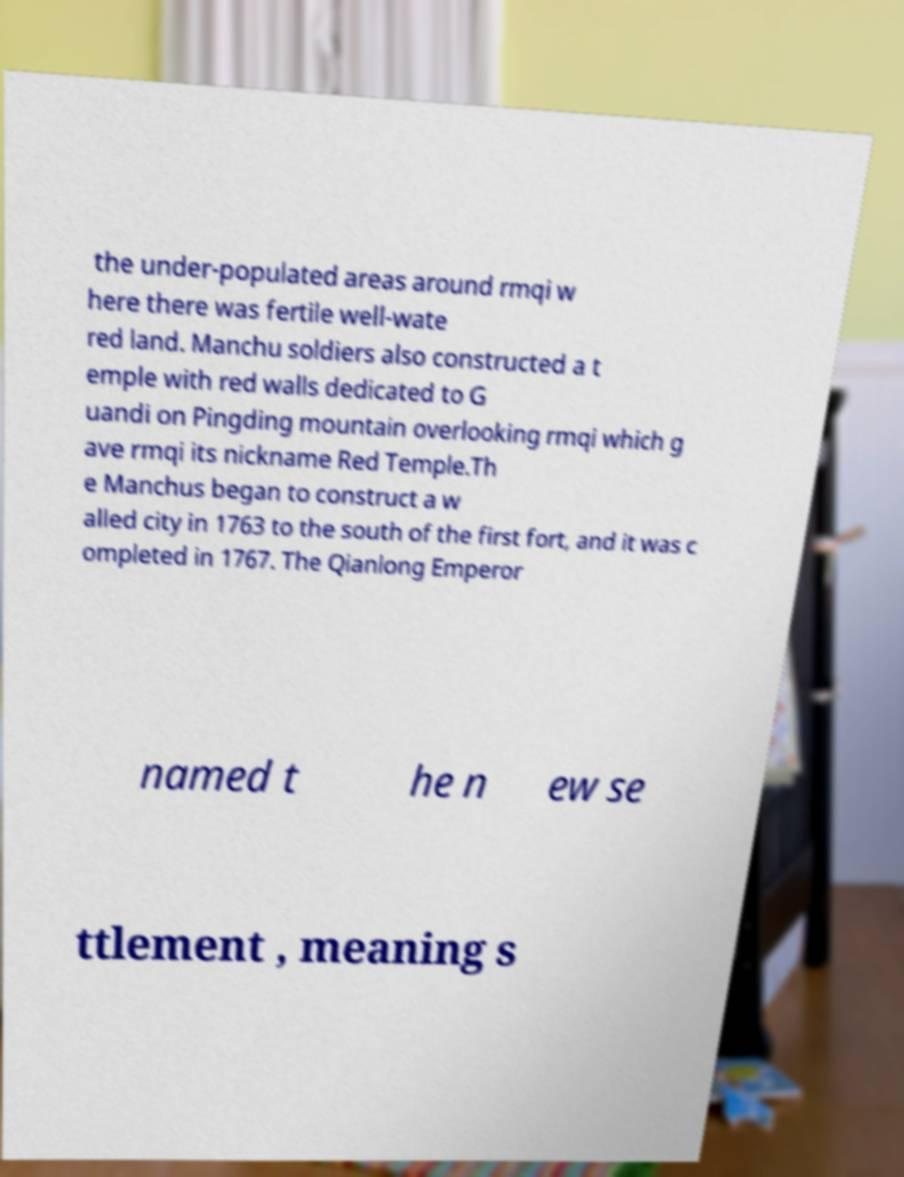Please read and relay the text visible in this image. What does it say? the under-populated areas around rmqi w here there was fertile well-wate red land. Manchu soldiers also constructed a t emple with red walls dedicated to G uandi on Pingding mountain overlooking rmqi which g ave rmqi its nickname Red Temple.Th e Manchus began to construct a w alled city in 1763 to the south of the first fort, and it was c ompleted in 1767. The Qianlong Emperor named t he n ew se ttlement , meaning s 